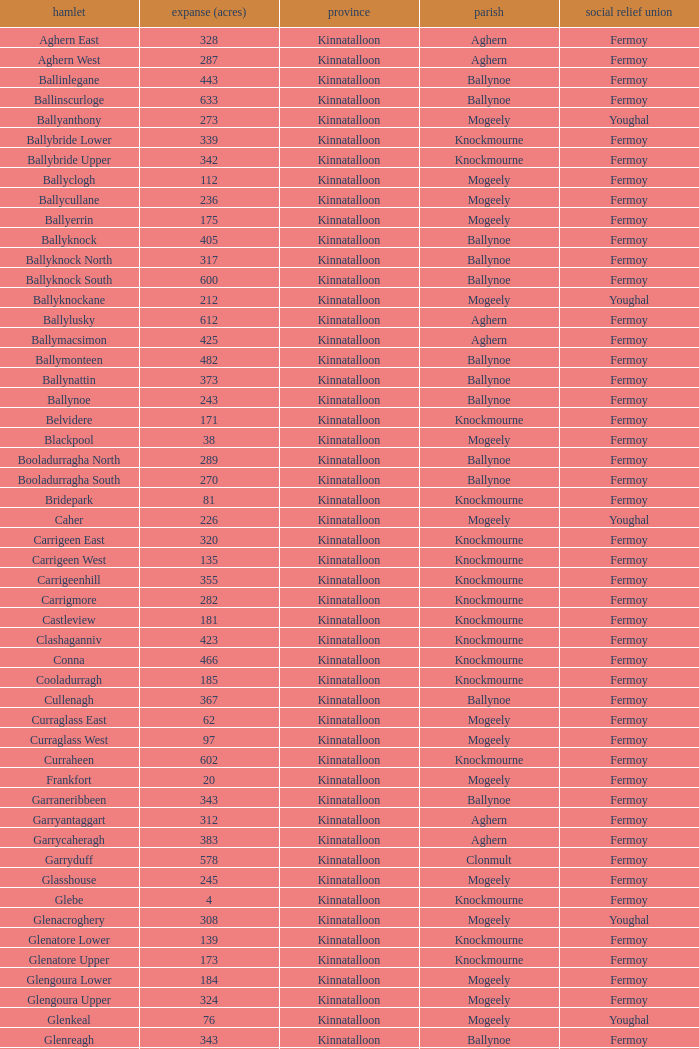Name  the townland for fermoy and ballynoe Ballinlegane, Ballinscurloge, Ballyknock, Ballyknock North, Ballyknock South, Ballymonteen, Ballynattin, Ballynoe, Booladurragha North, Booladurragha South, Cullenagh, Garraneribbeen, Glenreagh, Glentane, Killasseragh, Kilphillibeen, Knockakeo, Longueville North, Longueville South, Rathdrum, Shanaboola. Can you parse all the data within this table? {'header': ['hamlet', 'expanse (acres)', 'province', 'parish', 'social relief union'], 'rows': [['Aghern East', '328', 'Kinnatalloon', 'Aghern', 'Fermoy'], ['Aghern West', '287', 'Kinnatalloon', 'Aghern', 'Fermoy'], ['Ballinlegane', '443', 'Kinnatalloon', 'Ballynoe', 'Fermoy'], ['Ballinscurloge', '633', 'Kinnatalloon', 'Ballynoe', 'Fermoy'], ['Ballyanthony', '273', 'Kinnatalloon', 'Mogeely', 'Youghal'], ['Ballybride Lower', '339', 'Kinnatalloon', 'Knockmourne', 'Fermoy'], ['Ballybride Upper', '342', 'Kinnatalloon', 'Knockmourne', 'Fermoy'], ['Ballyclogh', '112', 'Kinnatalloon', 'Mogeely', 'Fermoy'], ['Ballycullane', '236', 'Kinnatalloon', 'Mogeely', 'Fermoy'], ['Ballyerrin', '175', 'Kinnatalloon', 'Mogeely', 'Fermoy'], ['Ballyknock', '405', 'Kinnatalloon', 'Ballynoe', 'Fermoy'], ['Ballyknock North', '317', 'Kinnatalloon', 'Ballynoe', 'Fermoy'], ['Ballyknock South', '600', 'Kinnatalloon', 'Ballynoe', 'Fermoy'], ['Ballyknockane', '212', 'Kinnatalloon', 'Mogeely', 'Youghal'], ['Ballylusky', '612', 'Kinnatalloon', 'Aghern', 'Fermoy'], ['Ballymacsimon', '425', 'Kinnatalloon', 'Aghern', 'Fermoy'], ['Ballymonteen', '482', 'Kinnatalloon', 'Ballynoe', 'Fermoy'], ['Ballynattin', '373', 'Kinnatalloon', 'Ballynoe', 'Fermoy'], ['Ballynoe', '243', 'Kinnatalloon', 'Ballynoe', 'Fermoy'], ['Belvidere', '171', 'Kinnatalloon', 'Knockmourne', 'Fermoy'], ['Blackpool', '38', 'Kinnatalloon', 'Mogeely', 'Fermoy'], ['Booladurragha North', '289', 'Kinnatalloon', 'Ballynoe', 'Fermoy'], ['Booladurragha South', '270', 'Kinnatalloon', 'Ballynoe', 'Fermoy'], ['Bridepark', '81', 'Kinnatalloon', 'Knockmourne', 'Fermoy'], ['Caher', '226', 'Kinnatalloon', 'Mogeely', 'Youghal'], ['Carrigeen East', '320', 'Kinnatalloon', 'Knockmourne', 'Fermoy'], ['Carrigeen West', '135', 'Kinnatalloon', 'Knockmourne', 'Fermoy'], ['Carrigeenhill', '355', 'Kinnatalloon', 'Knockmourne', 'Fermoy'], ['Carrigmore', '282', 'Kinnatalloon', 'Knockmourne', 'Fermoy'], ['Castleview', '181', 'Kinnatalloon', 'Knockmourne', 'Fermoy'], ['Clashaganniv', '423', 'Kinnatalloon', 'Knockmourne', 'Fermoy'], ['Conna', '466', 'Kinnatalloon', 'Knockmourne', 'Fermoy'], ['Cooladurragh', '185', 'Kinnatalloon', 'Knockmourne', 'Fermoy'], ['Cullenagh', '367', 'Kinnatalloon', 'Ballynoe', 'Fermoy'], ['Curraglass East', '62', 'Kinnatalloon', 'Mogeely', 'Fermoy'], ['Curraglass West', '97', 'Kinnatalloon', 'Mogeely', 'Fermoy'], ['Curraheen', '602', 'Kinnatalloon', 'Knockmourne', 'Fermoy'], ['Frankfort', '20', 'Kinnatalloon', 'Mogeely', 'Fermoy'], ['Garraneribbeen', '343', 'Kinnatalloon', 'Ballynoe', 'Fermoy'], ['Garryantaggart', '312', 'Kinnatalloon', 'Aghern', 'Fermoy'], ['Garrycaheragh', '383', 'Kinnatalloon', 'Aghern', 'Fermoy'], ['Garryduff', '578', 'Kinnatalloon', 'Clonmult', 'Fermoy'], ['Glasshouse', '245', 'Kinnatalloon', 'Mogeely', 'Fermoy'], ['Glebe', '4', 'Kinnatalloon', 'Knockmourne', 'Fermoy'], ['Glenacroghery', '308', 'Kinnatalloon', 'Mogeely', 'Youghal'], ['Glenatore Lower', '139', 'Kinnatalloon', 'Knockmourne', 'Fermoy'], ['Glenatore Upper', '173', 'Kinnatalloon', 'Knockmourne', 'Fermoy'], ['Glengoura Lower', '184', 'Kinnatalloon', 'Mogeely', 'Fermoy'], ['Glengoura Upper', '324', 'Kinnatalloon', 'Mogeely', 'Fermoy'], ['Glenkeal', '76', 'Kinnatalloon', 'Mogeely', 'Youghal'], ['Glenreagh', '343', 'Kinnatalloon', 'Ballynoe', 'Fermoy'], ['Glentane', '274', 'Kinnatalloon', 'Ballynoe', 'Fermoy'], ['Glentrasna', '284', 'Kinnatalloon', 'Aghern', 'Fermoy'], ['Glentrasna North', '219', 'Kinnatalloon', 'Aghern', 'Fermoy'], ['Glentrasna South', '220', 'Kinnatalloon', 'Aghern', 'Fermoy'], ['Gortnafira', '78', 'Kinnatalloon', 'Mogeely', 'Fermoy'], ['Inchyallagh', '8', 'Kinnatalloon', 'Mogeely', 'Fermoy'], ['Kilclare Lower', '109', 'Kinnatalloon', 'Knockmourne', 'Fermoy'], ['Kilclare Upper', '493', 'Kinnatalloon', 'Knockmourne', 'Fermoy'], ['Kilcronat', '516', 'Kinnatalloon', 'Mogeely', 'Youghal'], ['Kilcronatmountain', '385', 'Kinnatalloon', 'Mogeely', 'Youghal'], ['Killasseragh', '340', 'Kinnatalloon', 'Ballynoe', 'Fermoy'], ['Killavarilly', '372', 'Kinnatalloon', 'Knockmourne', 'Fermoy'], ['Kilmacow', '316', 'Kinnatalloon', 'Mogeely', 'Fermoy'], ['Kilnafurrery', '256', 'Kinnatalloon', 'Mogeely', 'Youghal'], ['Kilphillibeen', '535', 'Kinnatalloon', 'Ballynoe', 'Fermoy'], ['Knockacool', '404', 'Kinnatalloon', 'Mogeely', 'Youghal'], ['Knockakeo', '296', 'Kinnatalloon', 'Ballynoe', 'Fermoy'], ['Knockanarrig', '215', 'Kinnatalloon', 'Mogeely', 'Youghal'], ['Knockastickane', '164', 'Kinnatalloon', 'Knockmourne', 'Fermoy'], ['Knocknagapple', '293', 'Kinnatalloon', 'Aghern', 'Fermoy'], ['Lackbrack', '84', 'Kinnatalloon', 'Mogeely', 'Fermoy'], ['Lacken', '262', 'Kinnatalloon', 'Mogeely', 'Youghal'], ['Lackenbehy', '101', 'Kinnatalloon', 'Mogeely', 'Fermoy'], ['Limekilnclose', '41', 'Kinnatalloon', 'Mogeely', 'Lismore'], ['Lisnabrin Lower', '114', 'Kinnatalloon', 'Mogeely', 'Fermoy'], ['Lisnabrin North', '217', 'Kinnatalloon', 'Mogeely', 'Fermoy'], ['Lisnabrin South', '180', 'Kinnatalloon', 'Mogeely', 'Fermoy'], ['Lisnabrinlodge', '28', 'Kinnatalloon', 'Mogeely', 'Fermoy'], ['Littlegrace', '50', 'Kinnatalloon', 'Knockmourne', 'Lismore'], ['Longueville North', '355', 'Kinnatalloon', 'Ballynoe', 'Fermoy'], ['Longueville South', '271', 'Kinnatalloon', 'Ballynoe', 'Fermoy'], ['Lyre', '160', 'Kinnatalloon', 'Mogeely', 'Youghal'], ['Lyre Mountain', '360', 'Kinnatalloon', 'Mogeely', 'Youghal'], ['Mogeely Lower', '304', 'Kinnatalloon', 'Mogeely', 'Fermoy'], ['Mogeely Upper', '247', 'Kinnatalloon', 'Mogeely', 'Fermoy'], ['Monagown', '491', 'Kinnatalloon', 'Knockmourne', 'Fermoy'], ['Monaloo', '458', 'Kinnatalloon', 'Mogeely', 'Youghal'], ['Mountprospect', '102', 'Kinnatalloon', 'Mogeely', 'Fermoy'], ['Park', '119', 'Kinnatalloon', 'Aghern', 'Fermoy'], ['Poundfields', '15', 'Kinnatalloon', 'Mogeely', 'Fermoy'], ['Rathdrum', '336', 'Kinnatalloon', 'Ballynoe', 'Fermoy'], ['Rathdrum', '339', 'Kinnatalloon', 'Britway', 'Fermoy'], ['Reanduff', '318', 'Kinnatalloon', 'Mogeely', 'Youghal'], ['Rearour North', '208', 'Kinnatalloon', 'Mogeely', 'Youghal'], ['Rearour South', '223', 'Kinnatalloon', 'Mogeely', 'Youghal'], ['Rosybower', '105', 'Kinnatalloon', 'Mogeely', 'Fermoy'], ['Sandyhill', '263', 'Kinnatalloon', 'Mogeely', 'Youghal'], ['Shanaboola', '190', 'Kinnatalloon', 'Ballynoe', 'Fermoy'], ['Shanakill Lower', '244', 'Kinnatalloon', 'Mogeely', 'Fermoy'], ['Shanakill Upper', '244', 'Kinnatalloon', 'Mogeely', 'Fermoy'], ['Slieveadoctor', '260', 'Kinnatalloon', 'Mogeely', 'Fermoy'], ['Templevally', '330', 'Kinnatalloon', 'Mogeely', 'Fermoy'], ['Vinepark', '7', 'Kinnatalloon', 'Mogeely', 'Fermoy']]} 